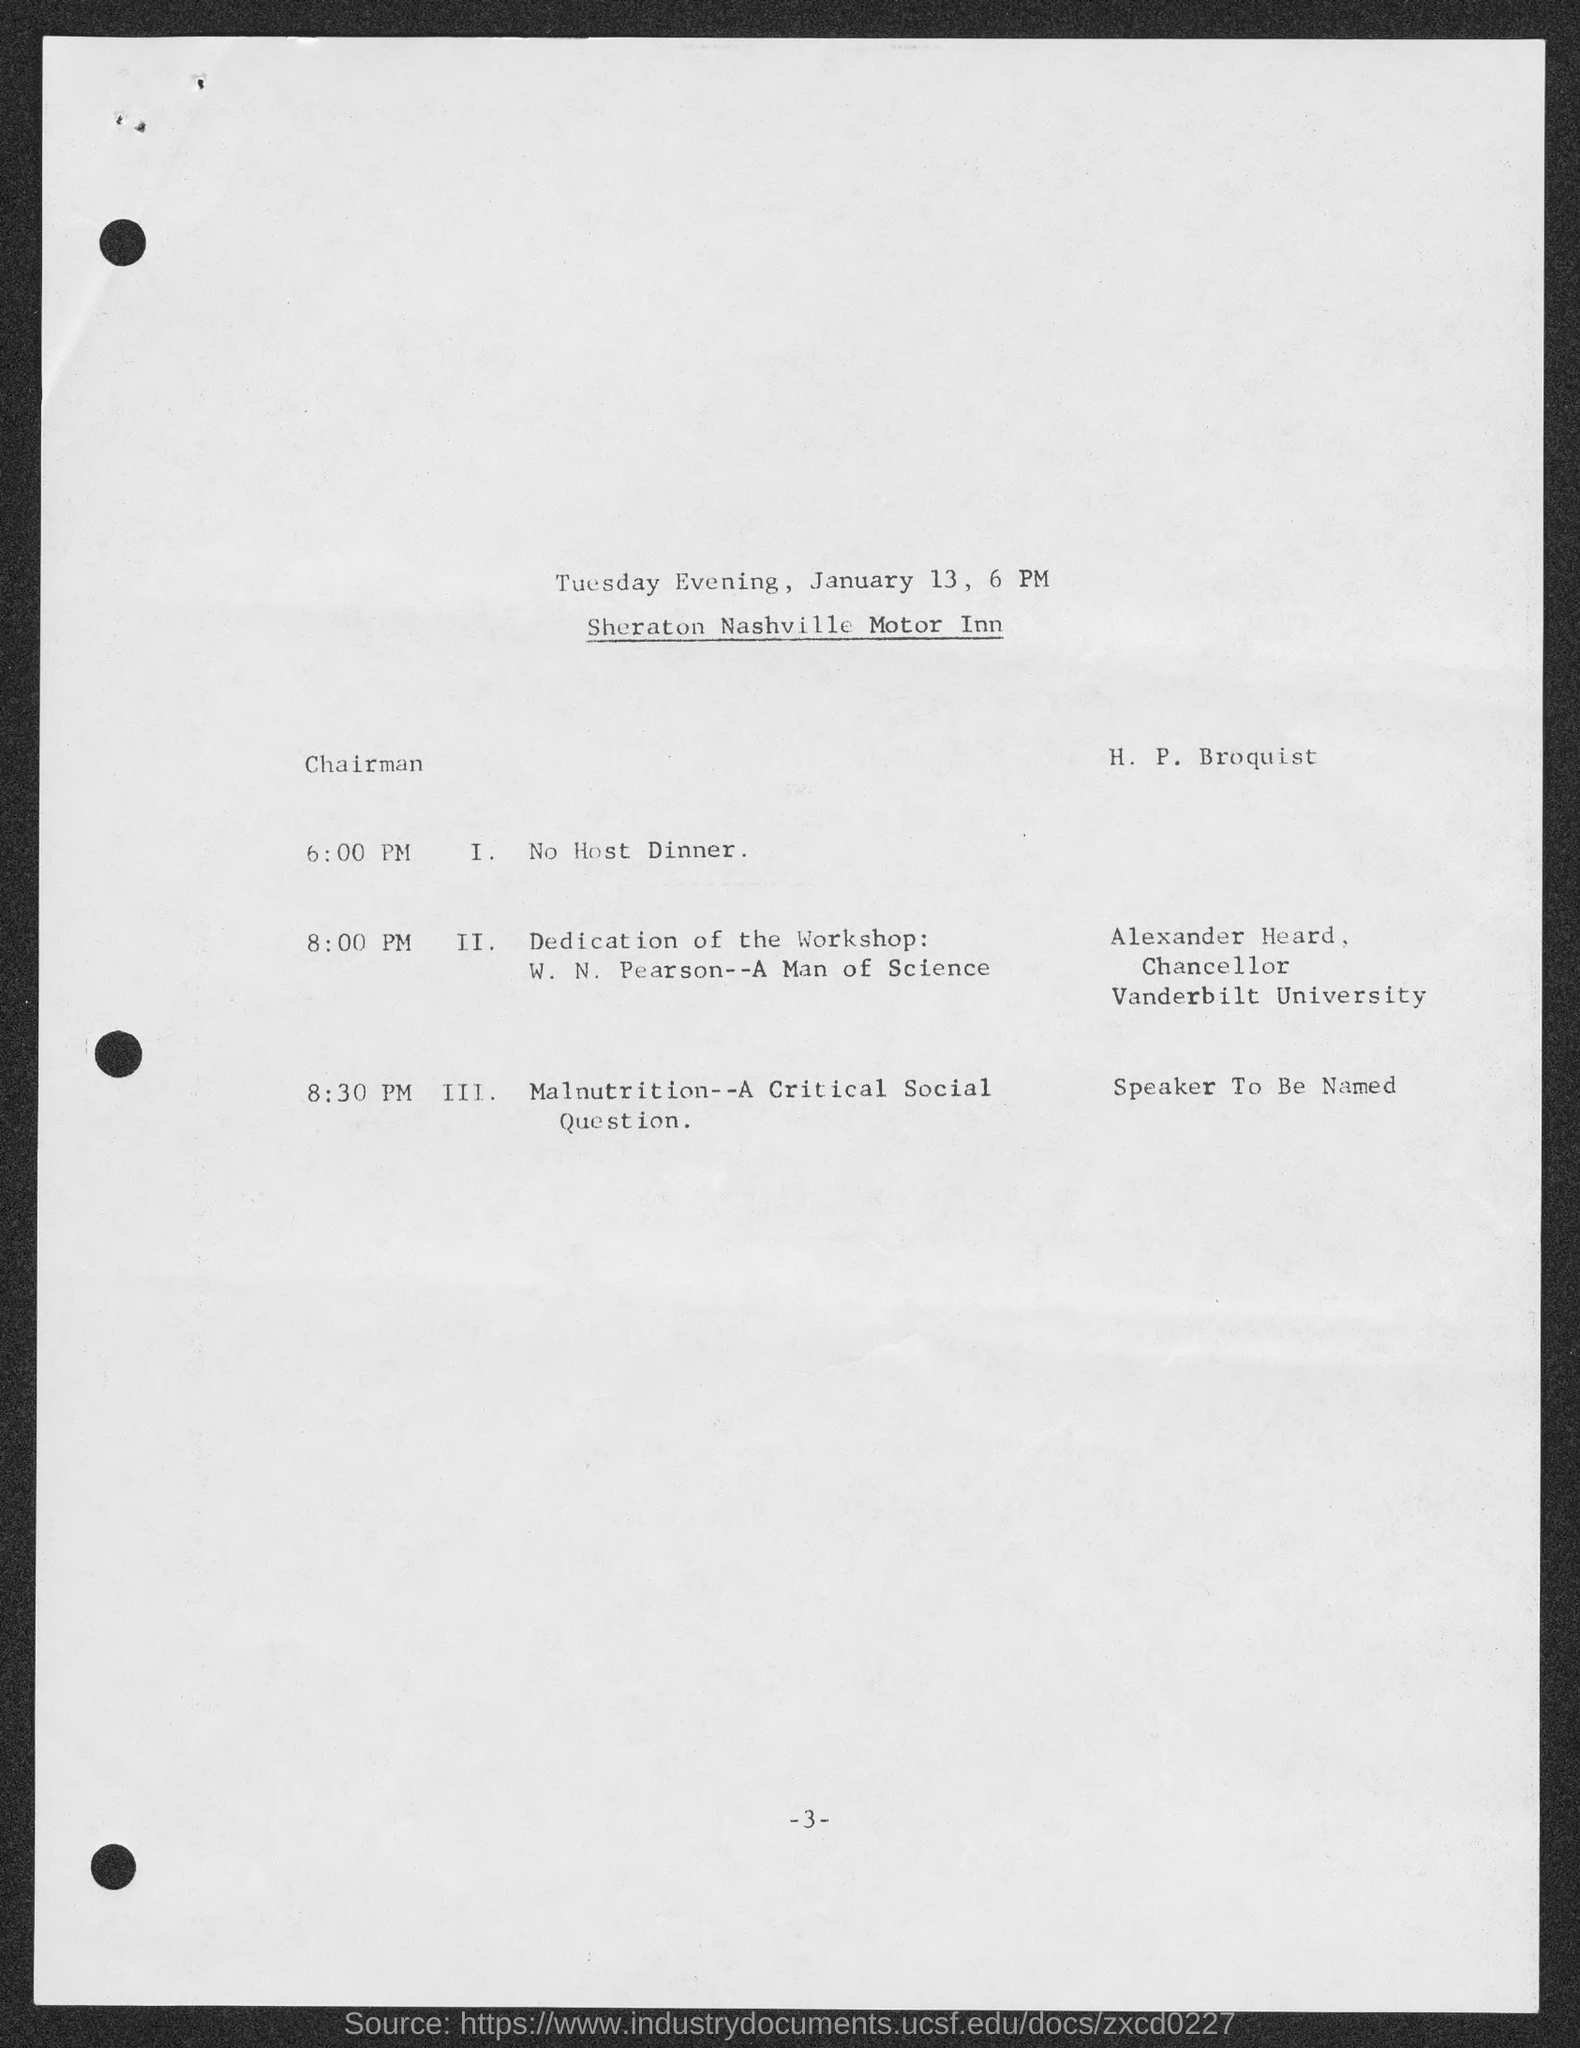Give some essential details in this illustration. Alexander Hearn has been designated as the Chancellor. The schedule at 8:00 pm is as follows: [insert schedule details here]. At the dedication of the workshop, [insert dedication details here]. Alexander belongs to Vanderbilt University. The date mentioned in the given page is January 13. 